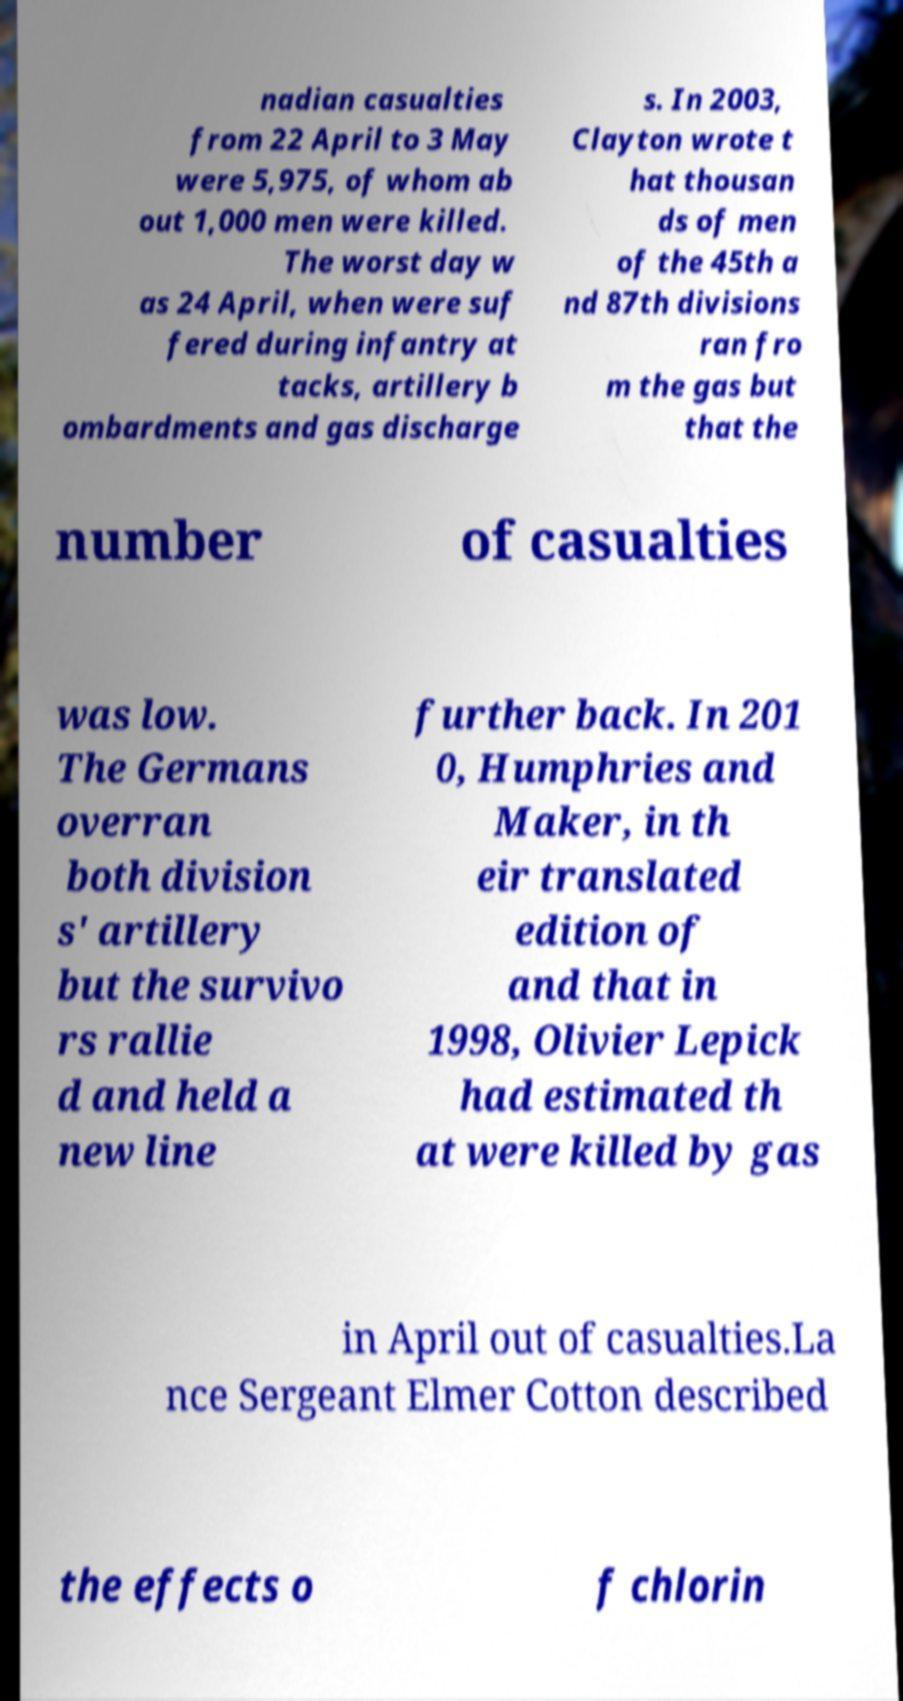There's text embedded in this image that I need extracted. Can you transcribe it verbatim? nadian casualties from 22 April to 3 May were 5,975, of whom ab out 1,000 men were killed. The worst day w as 24 April, when were suf fered during infantry at tacks, artillery b ombardments and gas discharge s. In 2003, Clayton wrote t hat thousan ds of men of the 45th a nd 87th divisions ran fro m the gas but that the number of casualties was low. The Germans overran both division s' artillery but the survivo rs rallie d and held a new line further back. In 201 0, Humphries and Maker, in th eir translated edition of and that in 1998, Olivier Lepick had estimated th at were killed by gas in April out of casualties.La nce Sergeant Elmer Cotton described the effects o f chlorin 